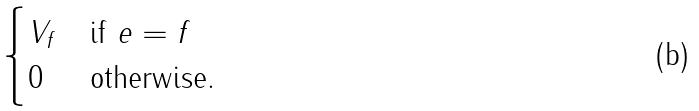<formula> <loc_0><loc_0><loc_500><loc_500>\begin{cases} V _ { f } & \text {if $e=f$} \\ 0 & \text {otherwise.} \end{cases}</formula> 